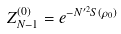Convert formula to latex. <formula><loc_0><loc_0><loc_500><loc_500>Z _ { N - 1 } ^ { ( 0 ) } = e ^ { - N ^ { \prime 2 } S ( \rho _ { 0 } ) }</formula> 